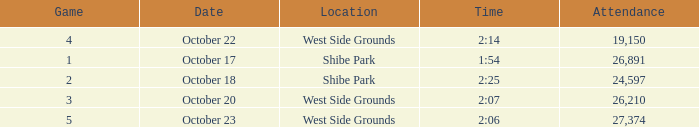For the game that was played on october 22 in west side grounds, what is the total attendance 1.0. Would you be able to parse every entry in this table? {'header': ['Game', 'Date', 'Location', 'Time', 'Attendance'], 'rows': [['4', 'October 22', 'West Side Grounds', '2:14', '19,150'], ['1', 'October 17', 'Shibe Park', '1:54', '26,891'], ['2', 'October 18', 'Shibe Park', '2:25', '24,597'], ['3', 'October 20', 'West Side Grounds', '2:07', '26,210'], ['5', 'October 23', 'West Side Grounds', '2:06', '27,374']]} 